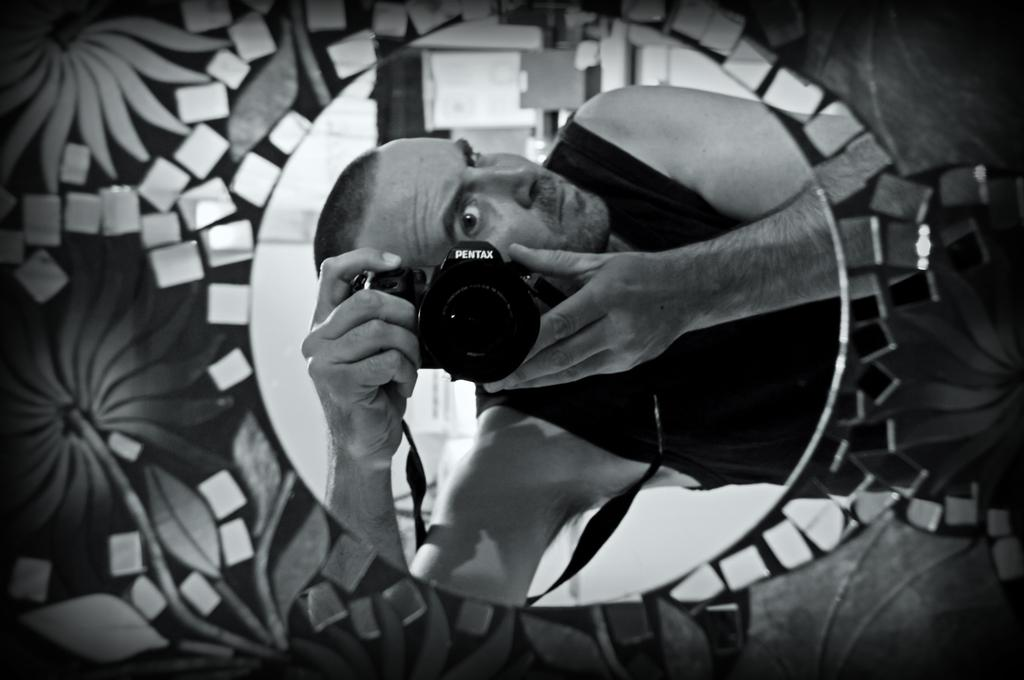What is the color scheme of the image? The image is black and white. What can be seen in the foreground of the image? There is a design board in the foreground. Can you describe the person in the image? There is a man in the image. What is the man holding in his hands? The man is holding a camera in his hands. How many brothers are present in the image? There is no mention of brothers in the image, as it only features a man holding a camera. What type of wheel can be seen attached to the camera? There is no wheel present on the camera in the image. 